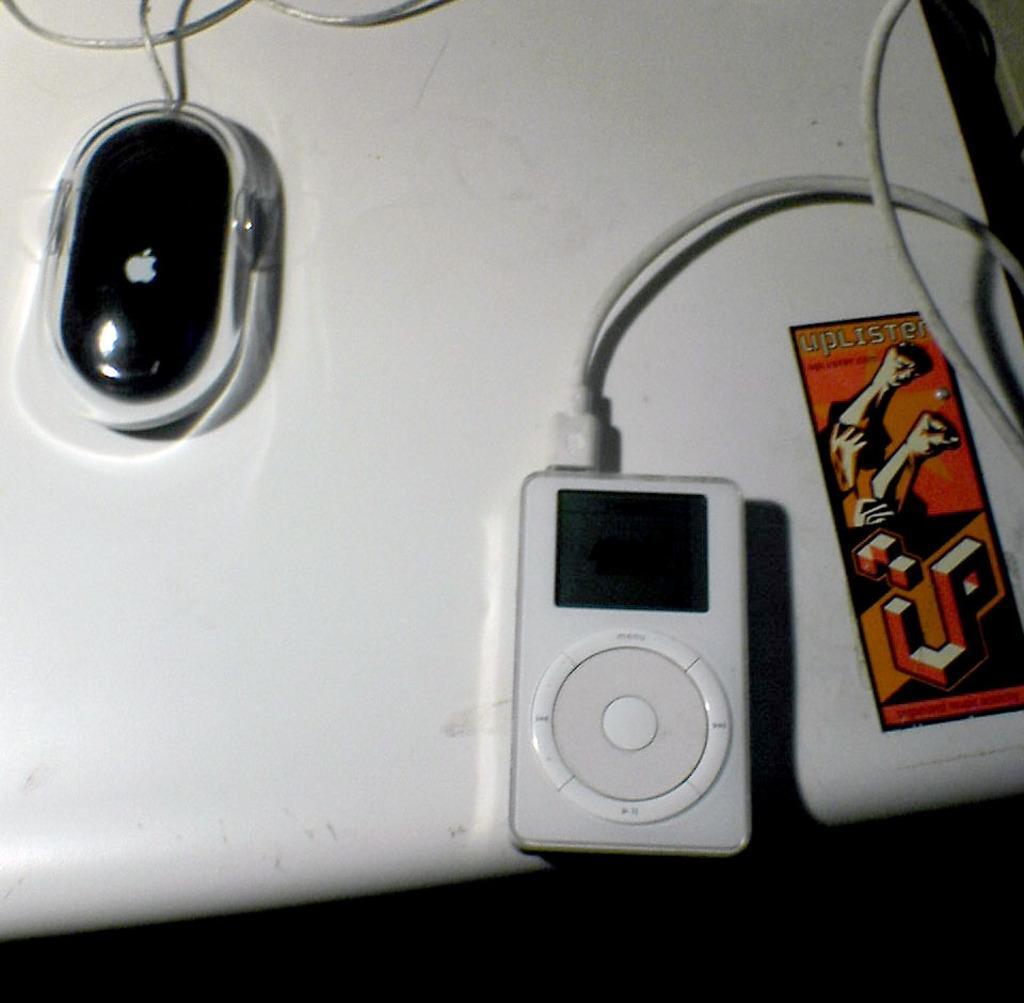How would you summarize this image in a sentence or two? In this image, we can see a white color table. On the right side, we can see a mobile and a paper attached to a table. On the left side of the table, we can see a mouse and some electrical wires. at the bottom, we can see black color. 